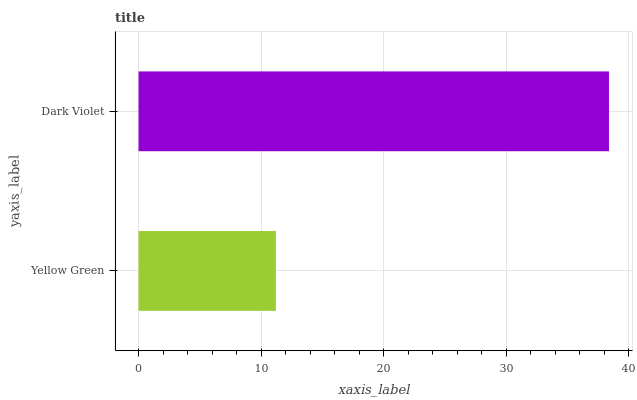Is Yellow Green the minimum?
Answer yes or no. Yes. Is Dark Violet the maximum?
Answer yes or no. Yes. Is Dark Violet the minimum?
Answer yes or no. No. Is Dark Violet greater than Yellow Green?
Answer yes or no. Yes. Is Yellow Green less than Dark Violet?
Answer yes or no. Yes. Is Yellow Green greater than Dark Violet?
Answer yes or no. No. Is Dark Violet less than Yellow Green?
Answer yes or no. No. Is Dark Violet the high median?
Answer yes or no. Yes. Is Yellow Green the low median?
Answer yes or no. Yes. Is Yellow Green the high median?
Answer yes or no. No. Is Dark Violet the low median?
Answer yes or no. No. 